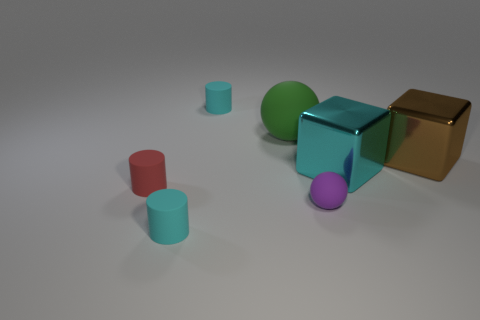Subtract all cyan matte cylinders. How many cylinders are left? 1 Add 1 blue metal cylinders. How many objects exist? 8 Subtract 1 spheres. How many spheres are left? 1 Subtract all blue cylinders. How many cyan balls are left? 0 Subtract all big red rubber blocks. Subtract all cyan objects. How many objects are left? 4 Add 6 balls. How many balls are left? 8 Add 1 cyan cubes. How many cyan cubes exist? 2 Subtract all brown cubes. How many cubes are left? 1 Subtract 0 blue balls. How many objects are left? 7 Subtract all balls. How many objects are left? 5 